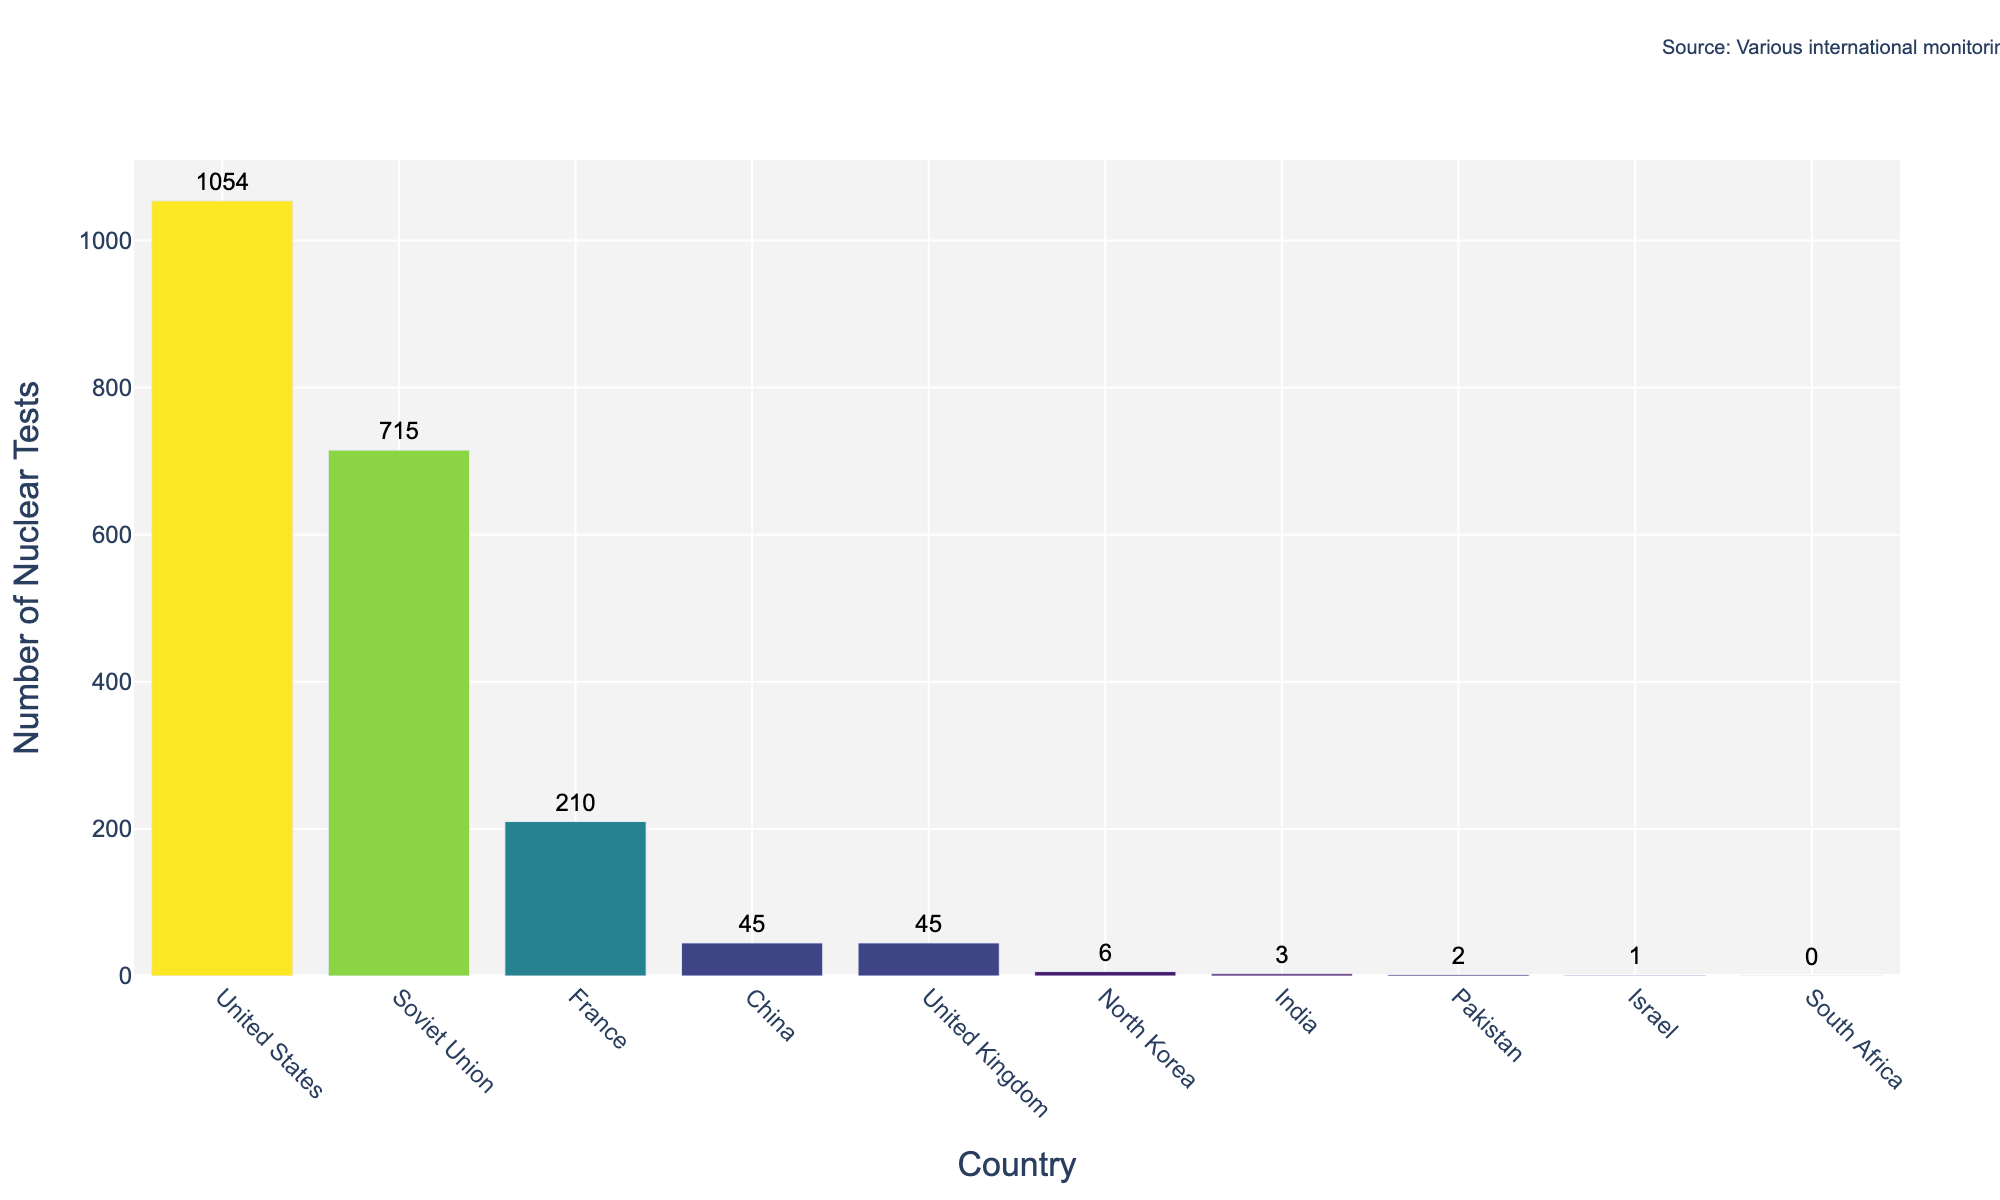Which country conducted the most nuclear tests? The bar for the United States is the tallest on the chart, indicating it conducted the most nuclear tests.
Answer: United States How many more nuclear tests did the United States conduct compared to the Soviet Union? The United States conducted 1054 tests and the Soviet Union conducted 715 tests. Subtracting 715 from 1054 gives the difference.
Answer: 339 Which countries conducted fewer than 50 nuclear tests? The bars for China, United Kingdom, North Korea, India, Pakistan, and Israel are all shorter and their values are below 50.
Answer: China, United Kingdom, North Korea, India, Pakistan, Israel What is the total number of nuclear tests conducted by China, the United Kingdom, and France combined? Add the number of tests conducted by China (45), United Kingdom (45), and France (210). The total is 45 + 45 + 210.
Answer: 300 What is the ratio of nuclear tests conducted by France to those conducted by China? Divide the number of nuclear tests conducted by France (210) by the number conducted by China (45). The ratio is 210/45.
Answer: 4.67 Which country has the least number of nuclear tests when excluding countries with no tests? The bar for Israel is the smallest among countries with bars, and it has 1 nuclear test.
Answer: Israel What is the average number of nuclear tests conducted by the United Kingdom and North Korea? Add the number of tests by the United Kingdom (45) and North Korea (6), then divide by 2. The average is (45 + 6) / 2.
Answer: 25.5 How many nuclear tests did India and Pakistan conduct in total? Add India's 3 tests and Pakistan's 2 tests. India and Pakistan together conducted 3 + 2 tests.
Answer: 5 Identify the countries with more nuclear tests than China. China's bar shows 45 tests. The taller bars correspond to United States, Soviet Union, and France, each with more than 45 tests.
Answer: United States, Soviet Union, France What's the difference in the number of nuclear tests between the United Kingdom and North Korea? Subtract the number of North Korea's tests (6) from the number of the United Kingdom's tests (45). The difference is 45 - 6.
Answer: 39 